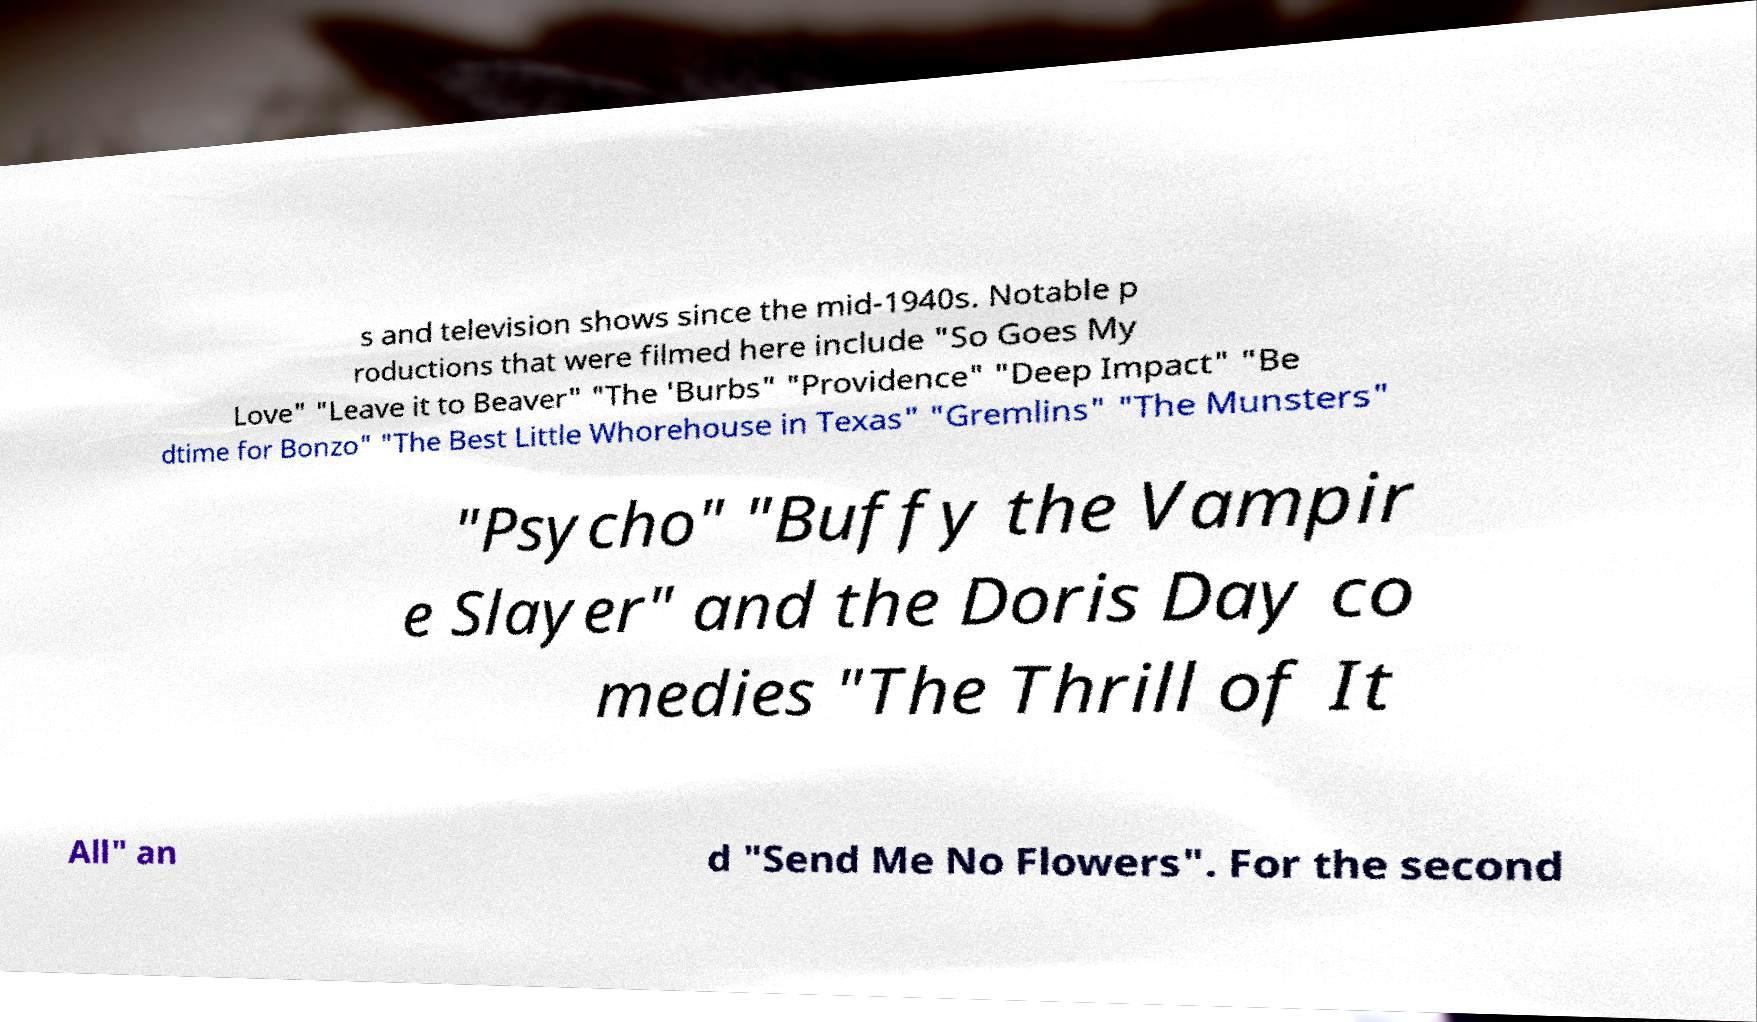Could you assist in decoding the text presented in this image and type it out clearly? s and television shows since the mid-1940s. Notable p roductions that were filmed here include "So Goes My Love" "Leave it to Beaver" "The 'Burbs" "Providence" "Deep Impact" "Be dtime for Bonzo" "The Best Little Whorehouse in Texas" "Gremlins" "The Munsters" "Psycho" "Buffy the Vampir e Slayer" and the Doris Day co medies "The Thrill of It All" an d "Send Me No Flowers". For the second 